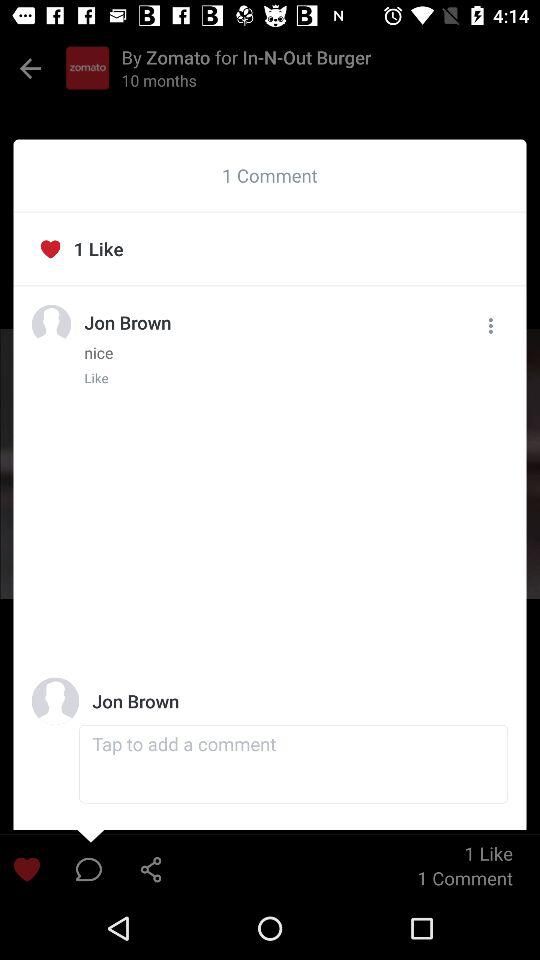What is the name of the person who commented? The name of the person is Jon Brown. 